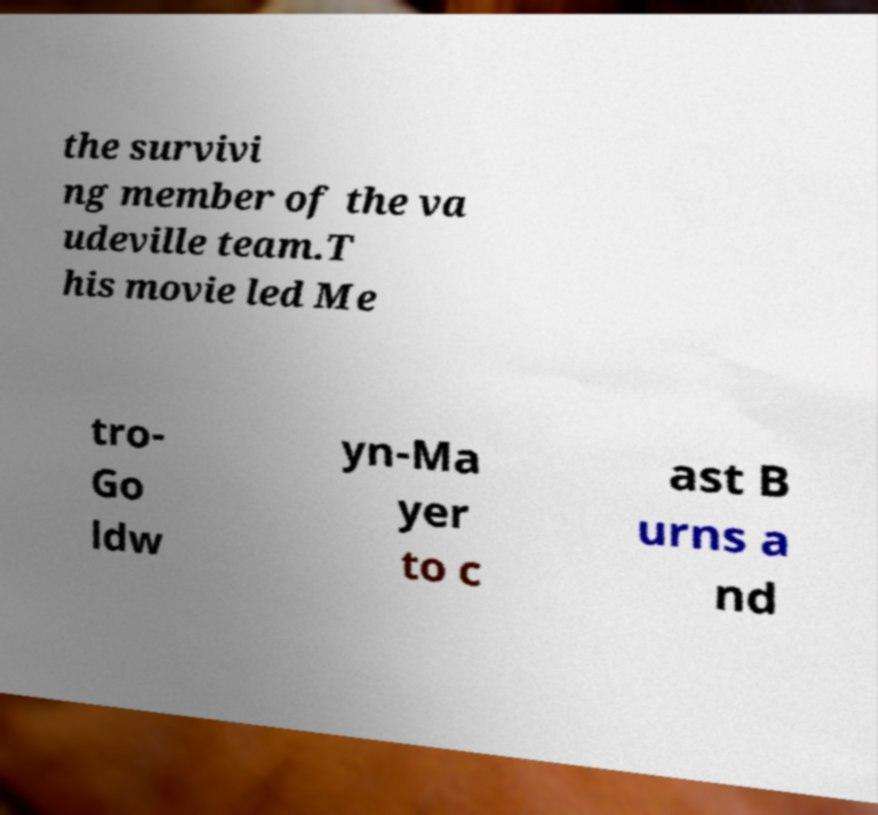Please read and relay the text visible in this image. What does it say? the survivi ng member of the va udeville team.T his movie led Me tro- Go ldw yn-Ma yer to c ast B urns a nd 